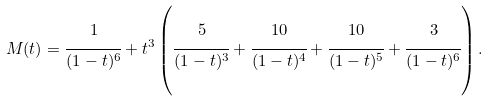<formula> <loc_0><loc_0><loc_500><loc_500>M ( t ) = \cfrac { 1 } { ( 1 - t ) ^ { 6 } } + t ^ { 3 } \left ( \cfrac { 5 } { ( 1 - t ) ^ { 3 } } + \cfrac { 1 0 } { ( 1 - t ) ^ { 4 } } + \cfrac { 1 0 } { ( 1 - t ) ^ { 5 } } + \cfrac { 3 } { ( 1 - t ) ^ { 6 } } \right ) .</formula> 